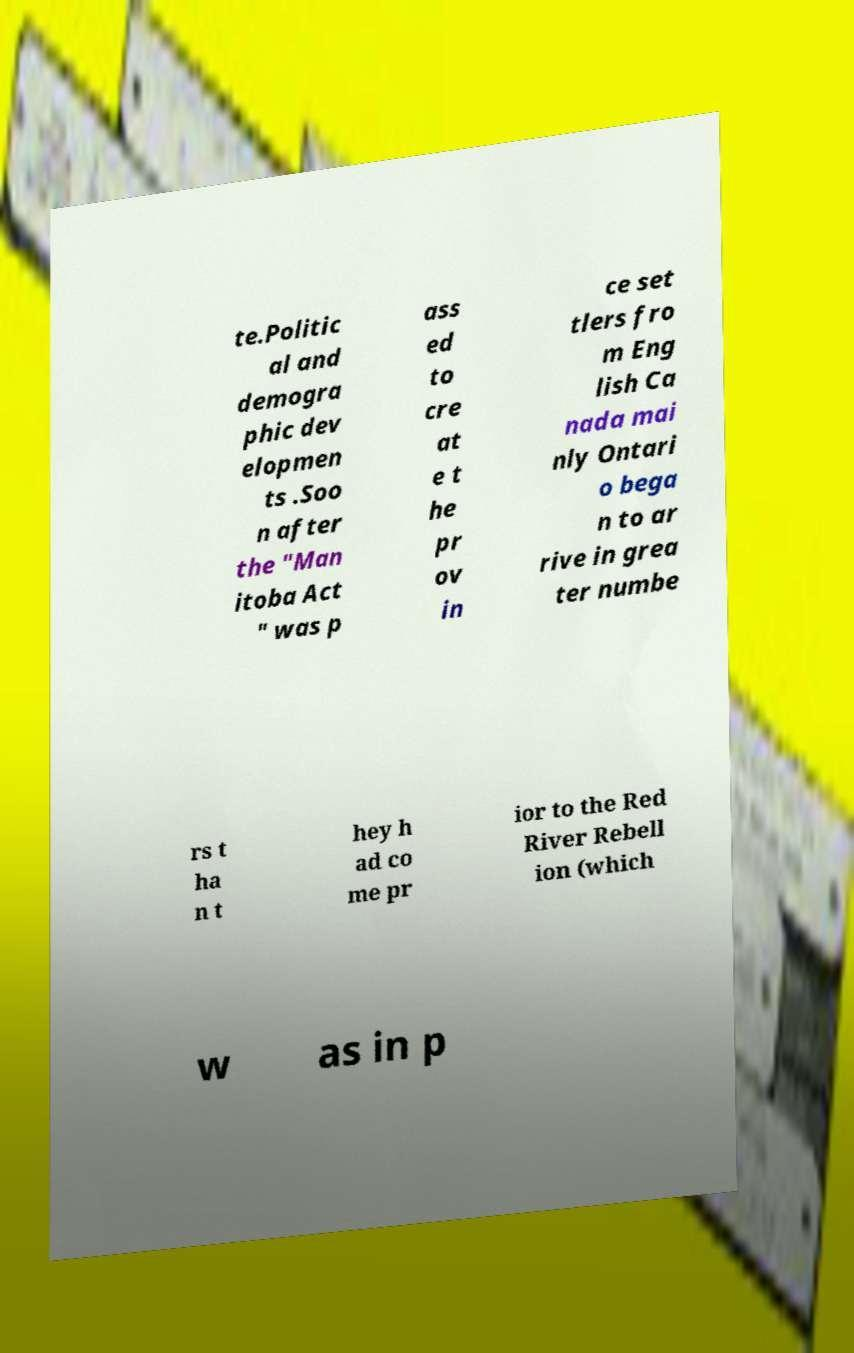Could you assist in decoding the text presented in this image and type it out clearly? te.Politic al and demogra phic dev elopmen ts .Soo n after the "Man itoba Act " was p ass ed to cre at e t he pr ov in ce set tlers fro m Eng lish Ca nada mai nly Ontari o bega n to ar rive in grea ter numbe rs t ha n t hey h ad co me pr ior to the Red River Rebell ion (which w as in p 